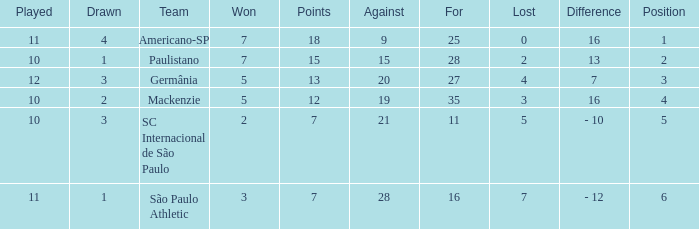Name the least for when played is 12 27.0. 